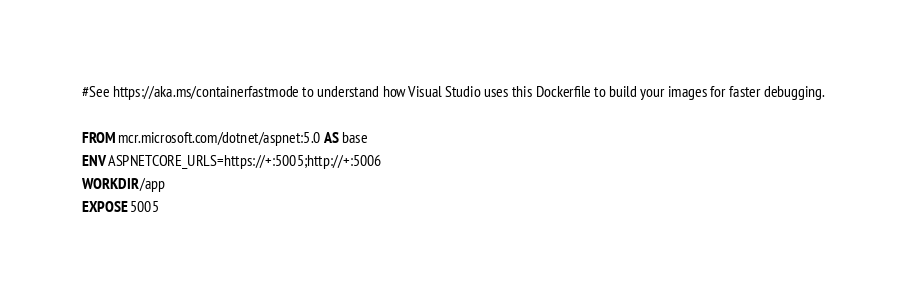Convert code to text. <code><loc_0><loc_0><loc_500><loc_500><_Dockerfile_>#See https://aka.ms/containerfastmode to understand how Visual Studio uses this Dockerfile to build your images for faster debugging.

FROM mcr.microsoft.com/dotnet/aspnet:5.0 AS base
ENV ASPNETCORE_URLS=https://+:5005;http://+:5006
WORKDIR /app
EXPOSE 5005</code> 